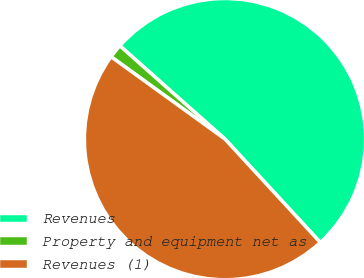Convert chart to OTSL. <chart><loc_0><loc_0><loc_500><loc_500><pie_chart><fcel>Revenues<fcel>Property and equipment net as<fcel>Revenues (1)<nl><fcel>51.59%<fcel>1.59%<fcel>46.82%<nl></chart> 